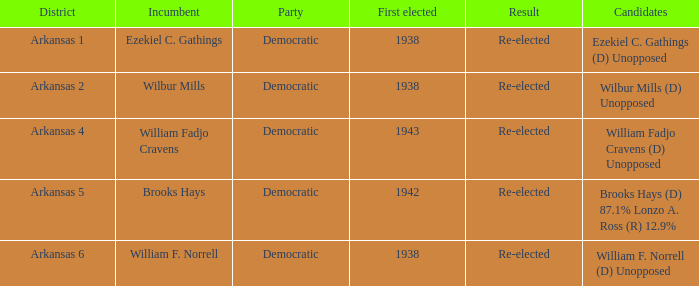To which political party did brooks hays, the incumbent, belong? Democratic. 